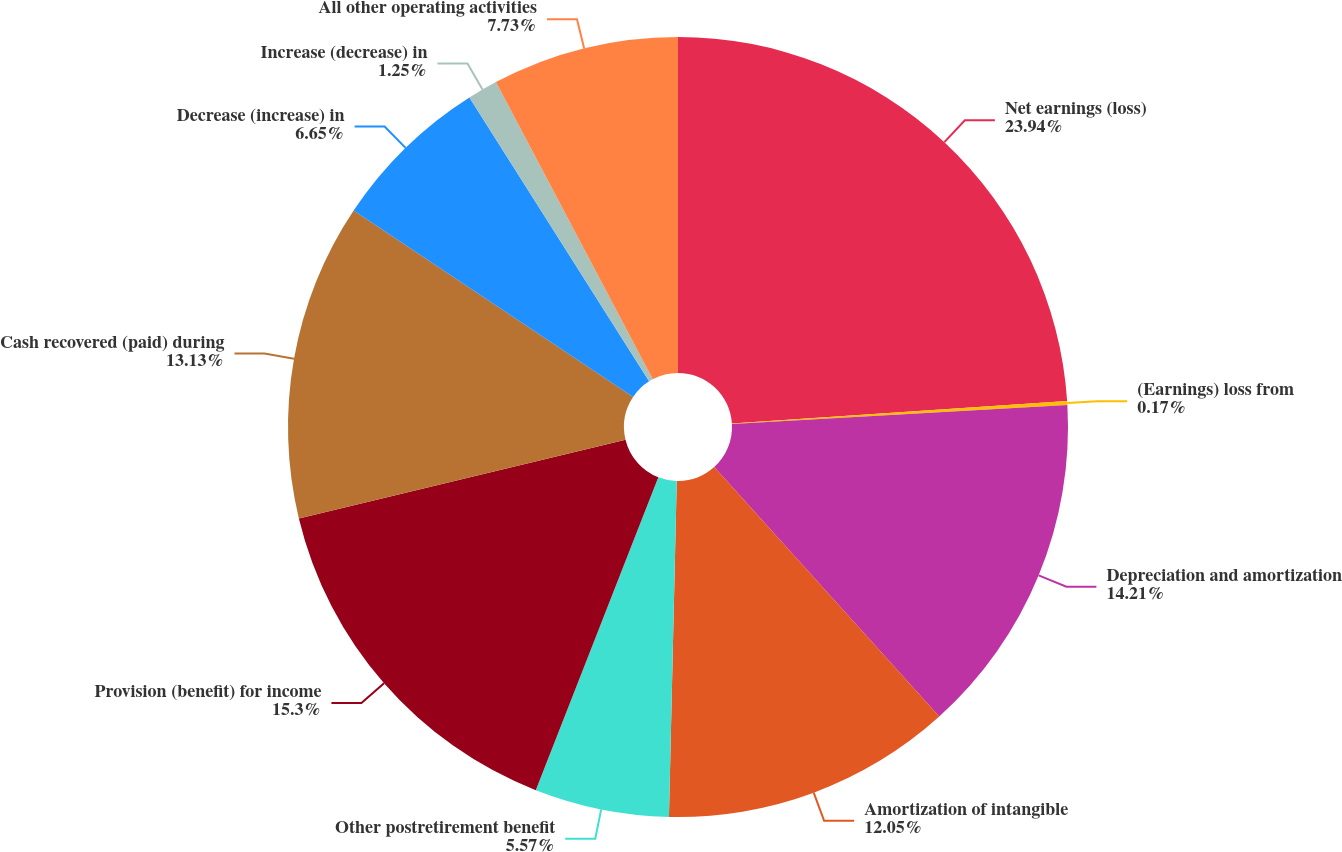Convert chart to OTSL. <chart><loc_0><loc_0><loc_500><loc_500><pie_chart><fcel>Net earnings (loss)<fcel>(Earnings) loss from<fcel>Depreciation and amortization<fcel>Amortization of intangible<fcel>Other postretirement benefit<fcel>Provision (benefit) for income<fcel>Cash recovered (paid) during<fcel>Decrease (increase) in<fcel>Increase (decrease) in<fcel>All other operating activities<nl><fcel>23.93%<fcel>0.17%<fcel>14.21%<fcel>12.05%<fcel>5.57%<fcel>15.29%<fcel>13.13%<fcel>6.65%<fcel>1.25%<fcel>7.73%<nl></chart> 